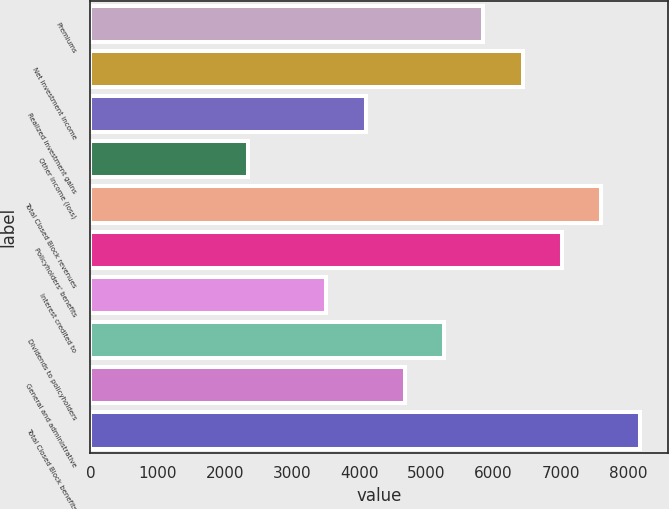Convert chart. <chart><loc_0><loc_0><loc_500><loc_500><bar_chart><fcel>Premiums<fcel>Net investment income<fcel>Realized investment gains<fcel>Other income (loss)<fcel>Total Closed Block revenues<fcel>Policyholders' benefits<fcel>Interest credited to<fcel>Dividends to policyholders<fcel>General and administrative<fcel>Total Closed Block benefits<nl><fcel>5847.03<fcel>6431.25<fcel>4094.37<fcel>2341.71<fcel>7599.69<fcel>7015.47<fcel>3510.15<fcel>5262.81<fcel>4678.59<fcel>8183.91<nl></chart> 